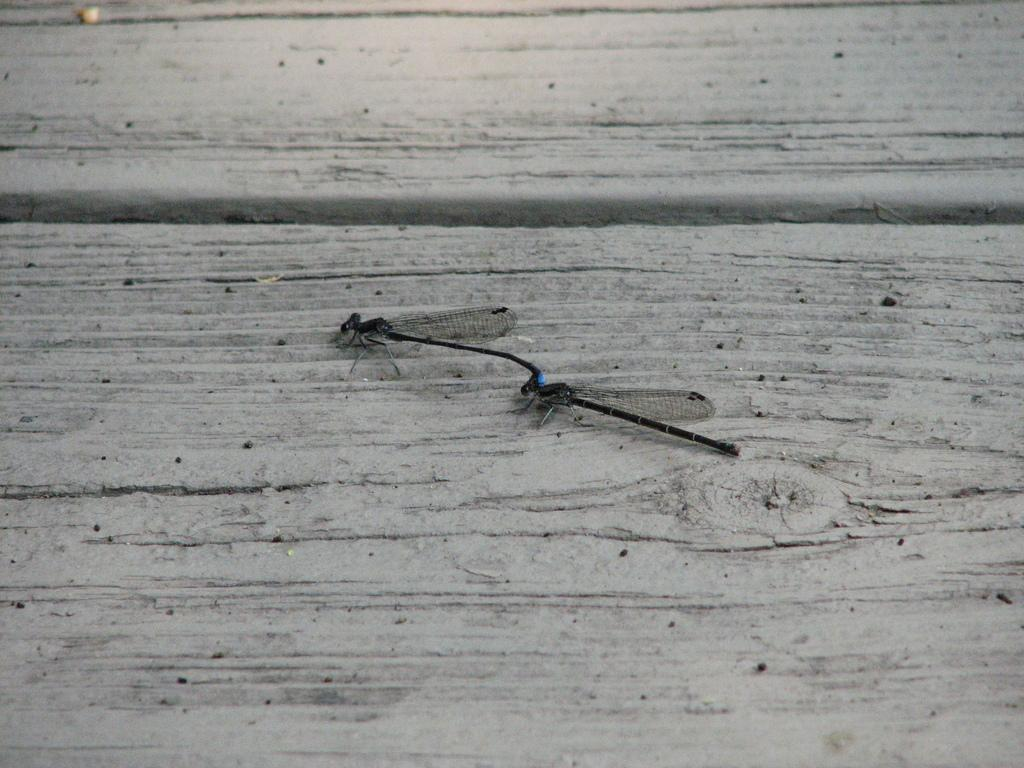What type of insects are depicted in the image? There are dragonflies in the image. Where are the dragonflies located on the wooden plank? The dragonflies are represented on a wooden plank. What type of care is provided to the dragonflies in the image? There is no indication in the image that the dragonflies are receiving any care. What type of education is being offered to the dragonflies in the image? There is no indication in the image that the dragonflies are receiving any education. 